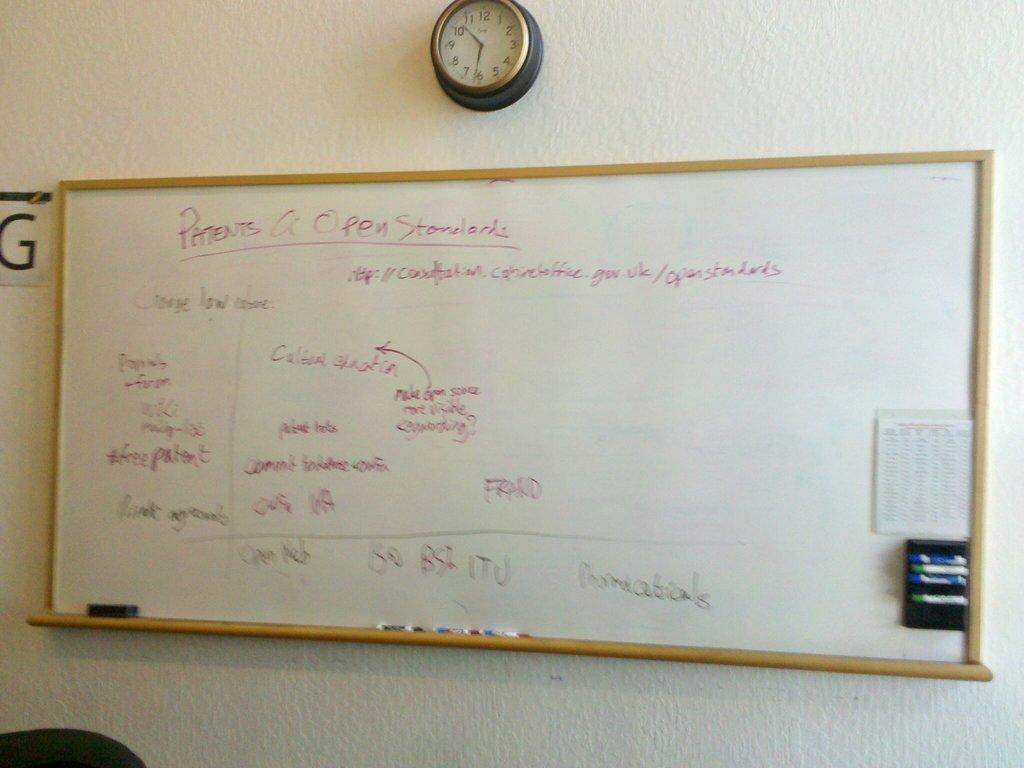What time is it?
Provide a succinct answer. 6:50. What letter i the the left side of the white board?
Offer a terse response. G. 